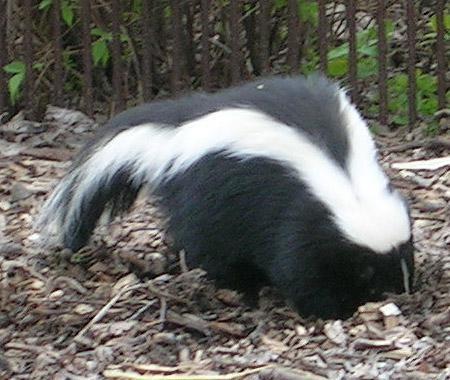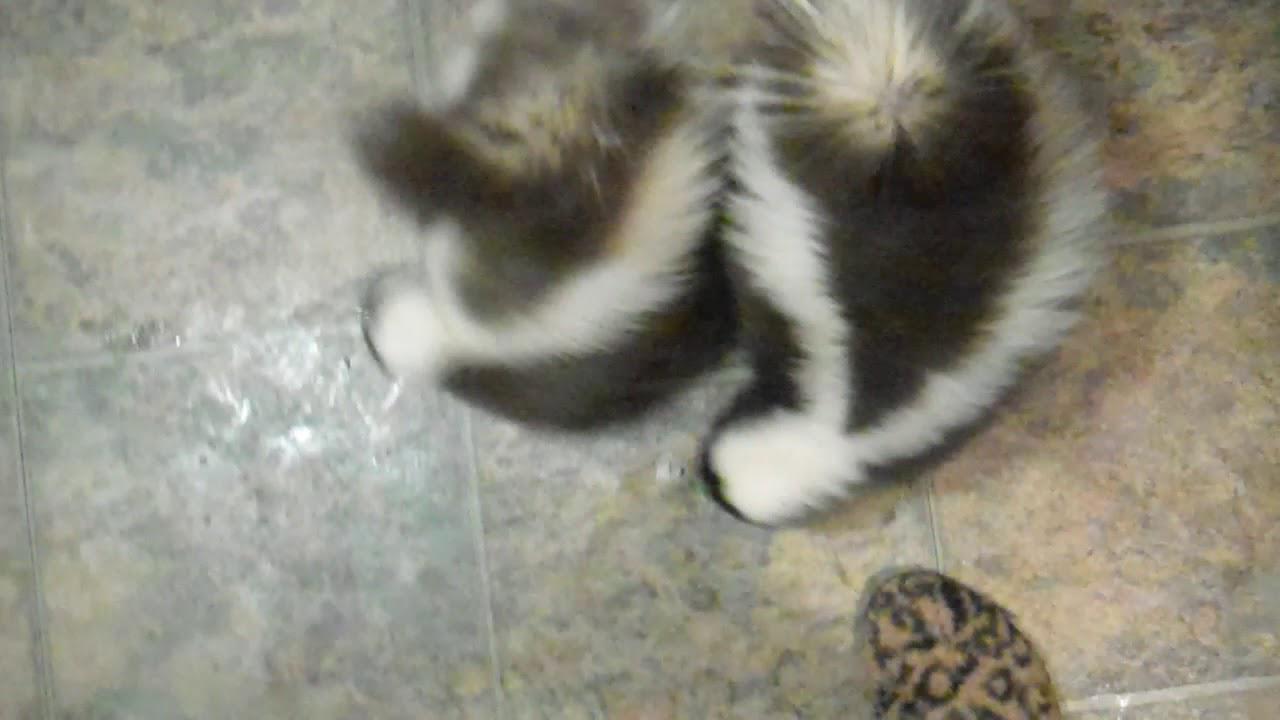The first image is the image on the left, the second image is the image on the right. For the images displayed, is the sentence "The right image shows one rightward-facing skunk with an oval food item in front of its nose." factually correct? Answer yes or no. No. The first image is the image on the left, the second image is the image on the right. Analyze the images presented: Is the assertion "There are only two skunks." valid? Answer yes or no. No. 